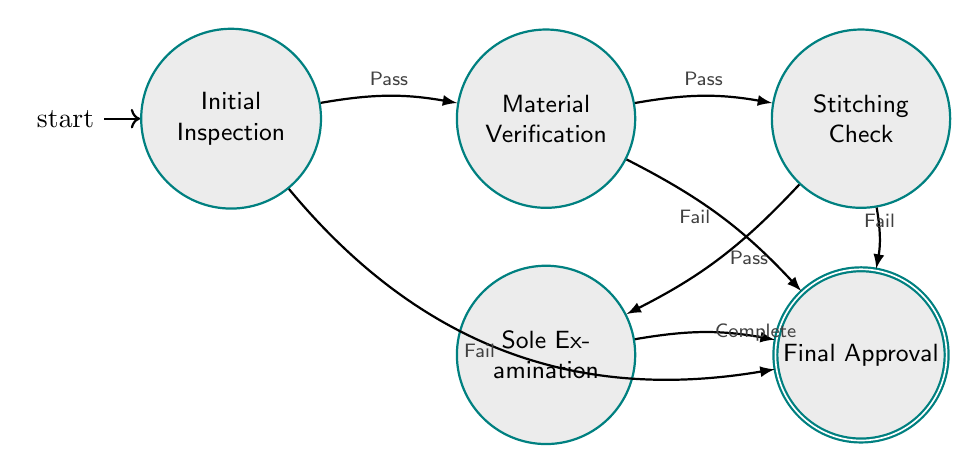What is the total number of states in the diagram? The diagram lists five individual states: Initial Inspection, Material Verification, Stitching Check, Sole Examination, and Final Approval. Counting these gives a total of five states.
Answer: 5 What state follows the Material Verification state on a pass? From the diagram, after the Material Verification state, if the check passes, the next state is the Stitching Check. This is indicated by the arrow labeled "Pass" connecting Material Verification to Stitching Check.
Answer: Stitching Check In which state does the process terminate if the Initial Inspection fails? The diagram shows that if the Initial Inspection fails, the process transitions directly to the Final Approval state. This is represented by the arrow indicating failure with the label "Fail", leading to Final Approval.
Answer: Final Approval What is the last state in the authentication workflow? Looking at the diagram, the Final Approval state is the last state in the authentication workflow, where the overall findings are reviewed, confirming authenticity or inauthenticity.
Answer: Final Approval How many transitions lead to the Final Approval state? There are four transitions leading to the Final Approval state as indicated in the diagram: two from Initial Inspection (Fail) and Material Verification (Fail), one from Stitching Check (Fail), and one from Sole Examination (Complete). Counting these connections yields four transitions.
Answer: 4 What is the nature of the transition from Sole Examination to Final Approval? The transition from Sole Examination to Final Approval is a completion check, signified by the label "Complete" on the arrow indicating that the sole examination has confirmed authenticity indicators.
Answer: Complete 